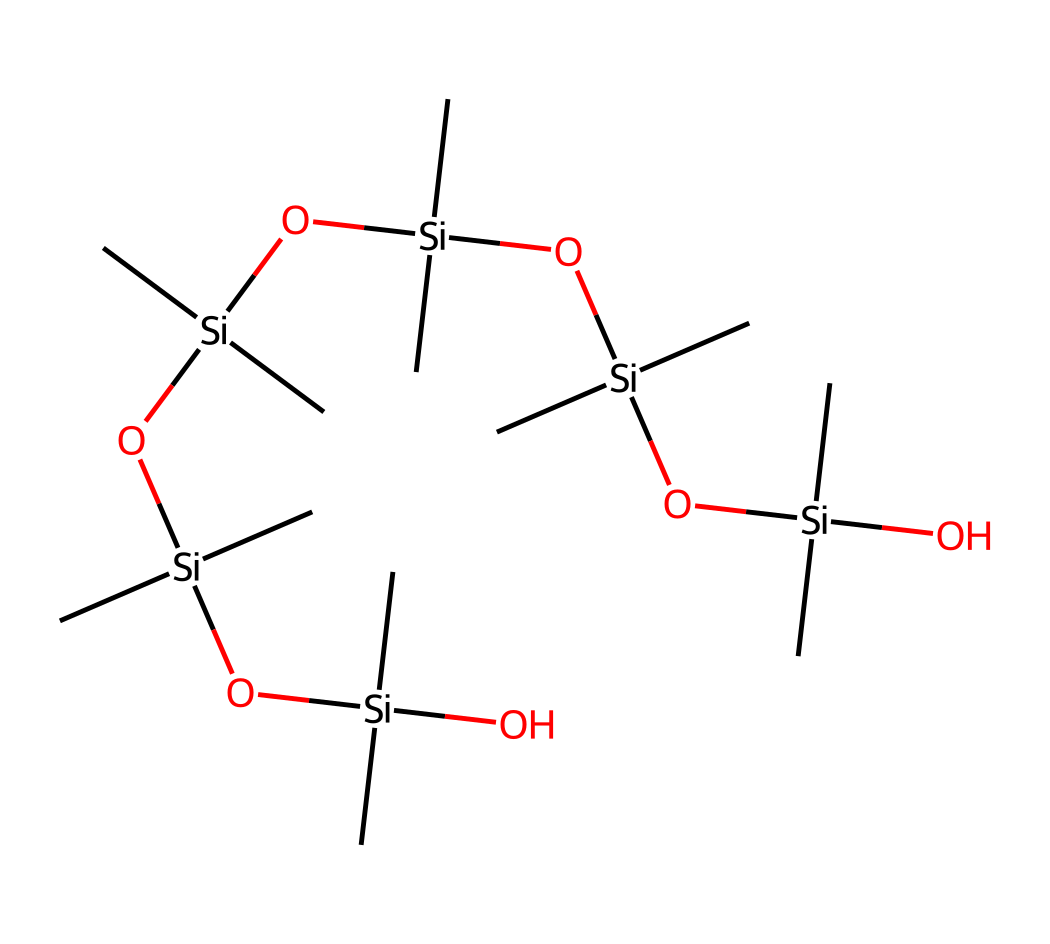How many silicon atoms are present in the chemical structure? In the provided SMILES representation, each occurrence of "Si" indicates a silicon atom. By counting these instances in the structure, we find a total of 6 silicon atoms.
Answer: 6 What functional groups are present in this chemical? Looking closely at the structure, we can identify hydroxyl (-OH) groups bonded to silicon atoms as part of the siloxane polymer structure. These -OH groups are characteristic of dimethicone.
Answer: hydroxyl groups What is the primary use of dimethicone in hand lotions? Dimethicone is commonly used in cosmetic formulations for its effective moisturizing properties and to create a smooth feel on the skin, which is essential in hand lotions after frequent washing.
Answer: moisturizing How many carbon atoms are in the chemical structure? The presence of "C" in the SMILES indicates carbon atoms. By carefully counting all instances of "C" in the structure, we find there are 18 carbon atoms in total.
Answer: 18 What type of chemical compound is dimethicone classified as? Dimethicone is classified as a silicone compound, which is characterized by a repeating unit of silicon-oxygen groups along with organic side chains of carbon. This classifies it as a silicone polymer.
Answer: silicone Does this chemical contain any nitrogen atoms? Upon reviewing the SMILES structure, there are no indications of nitrogen atoms being present, as there are no "N" symbols in the representation.
Answer: no What characteristic texture does dimethicone provide to hand lotions? Dimethicone is known for imparting a silky, smooth texture, making products easier to apply and enhancing the spreadability on the skin, which is particularly important in hand lotions.
Answer: silky, smooth 